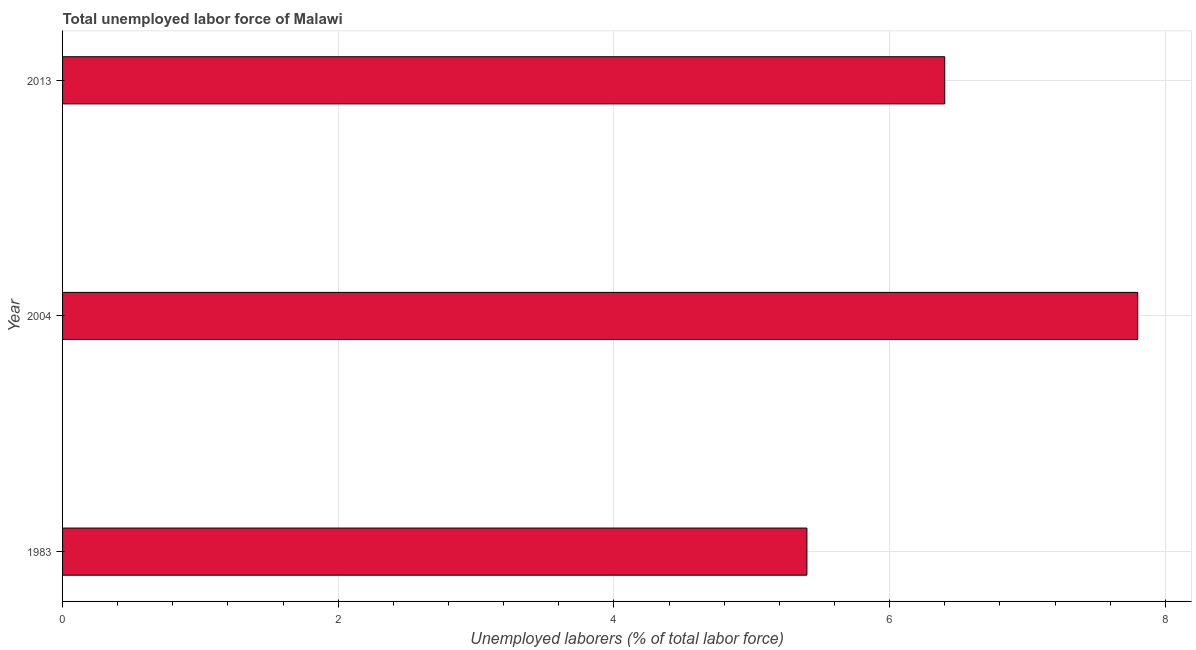Does the graph contain any zero values?
Offer a terse response. No. What is the title of the graph?
Make the answer very short. Total unemployed labor force of Malawi. What is the label or title of the X-axis?
Your answer should be very brief. Unemployed laborers (% of total labor force). What is the label or title of the Y-axis?
Ensure brevity in your answer.  Year. What is the total unemployed labour force in 1983?
Offer a terse response. 5.4. Across all years, what is the maximum total unemployed labour force?
Your answer should be very brief. 7.8. Across all years, what is the minimum total unemployed labour force?
Ensure brevity in your answer.  5.4. What is the sum of the total unemployed labour force?
Ensure brevity in your answer.  19.6. What is the difference between the total unemployed labour force in 2004 and 2013?
Keep it short and to the point. 1.4. What is the average total unemployed labour force per year?
Ensure brevity in your answer.  6.53. What is the median total unemployed labour force?
Ensure brevity in your answer.  6.4. In how many years, is the total unemployed labour force greater than 4 %?
Keep it short and to the point. 3. Do a majority of the years between 2004 and 2013 (inclusive) have total unemployed labour force greater than 4.8 %?
Make the answer very short. Yes. What is the ratio of the total unemployed labour force in 2004 to that in 2013?
Keep it short and to the point. 1.22. Is the difference between the total unemployed labour force in 2004 and 2013 greater than the difference between any two years?
Your answer should be very brief. No. How many years are there in the graph?
Provide a succinct answer. 3. What is the Unemployed laborers (% of total labor force) in 1983?
Your answer should be compact. 5.4. What is the Unemployed laborers (% of total labor force) of 2004?
Offer a very short reply. 7.8. What is the Unemployed laborers (% of total labor force) in 2013?
Provide a succinct answer. 6.4. What is the difference between the Unemployed laborers (% of total labor force) in 1983 and 2004?
Provide a succinct answer. -2.4. What is the difference between the Unemployed laborers (% of total labor force) in 1983 and 2013?
Your answer should be very brief. -1. What is the difference between the Unemployed laborers (% of total labor force) in 2004 and 2013?
Give a very brief answer. 1.4. What is the ratio of the Unemployed laborers (% of total labor force) in 1983 to that in 2004?
Give a very brief answer. 0.69. What is the ratio of the Unemployed laborers (% of total labor force) in 1983 to that in 2013?
Offer a very short reply. 0.84. What is the ratio of the Unemployed laborers (% of total labor force) in 2004 to that in 2013?
Your response must be concise. 1.22. 